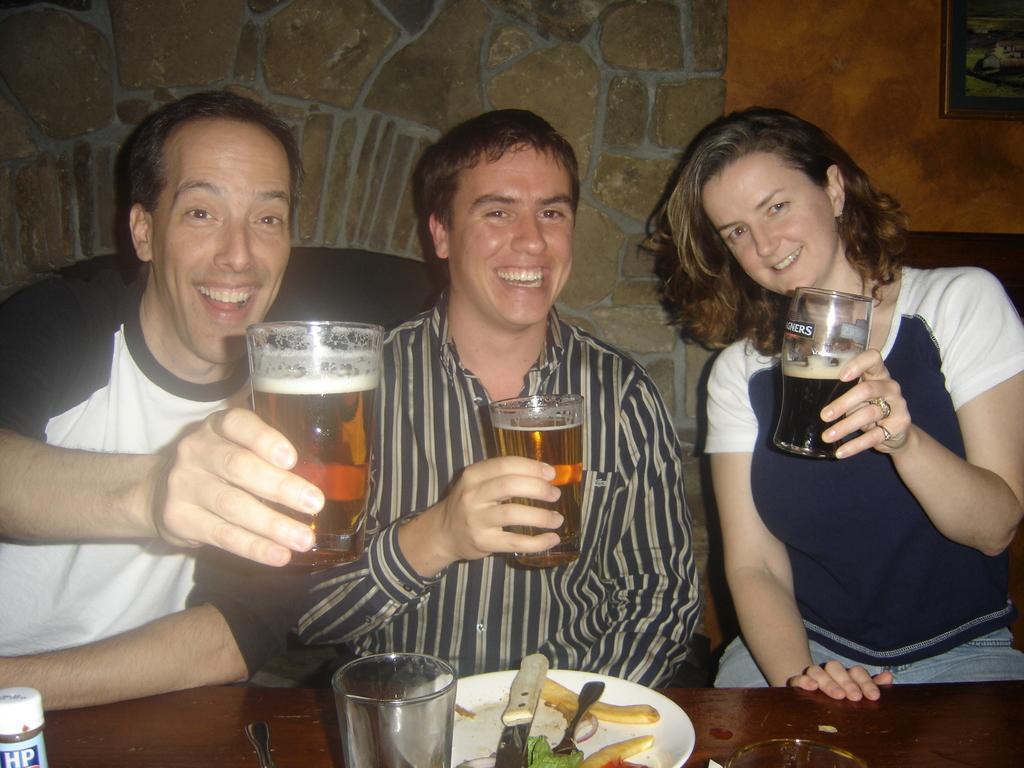Please provide a concise description of this image. there are three persons sitting and smiling holding glasses. In front of them there is a table. On the table there is a glass, plate, bottle, food items, fork and knife. In the background there is a brick wall. In the right corner there is a photo frame. 